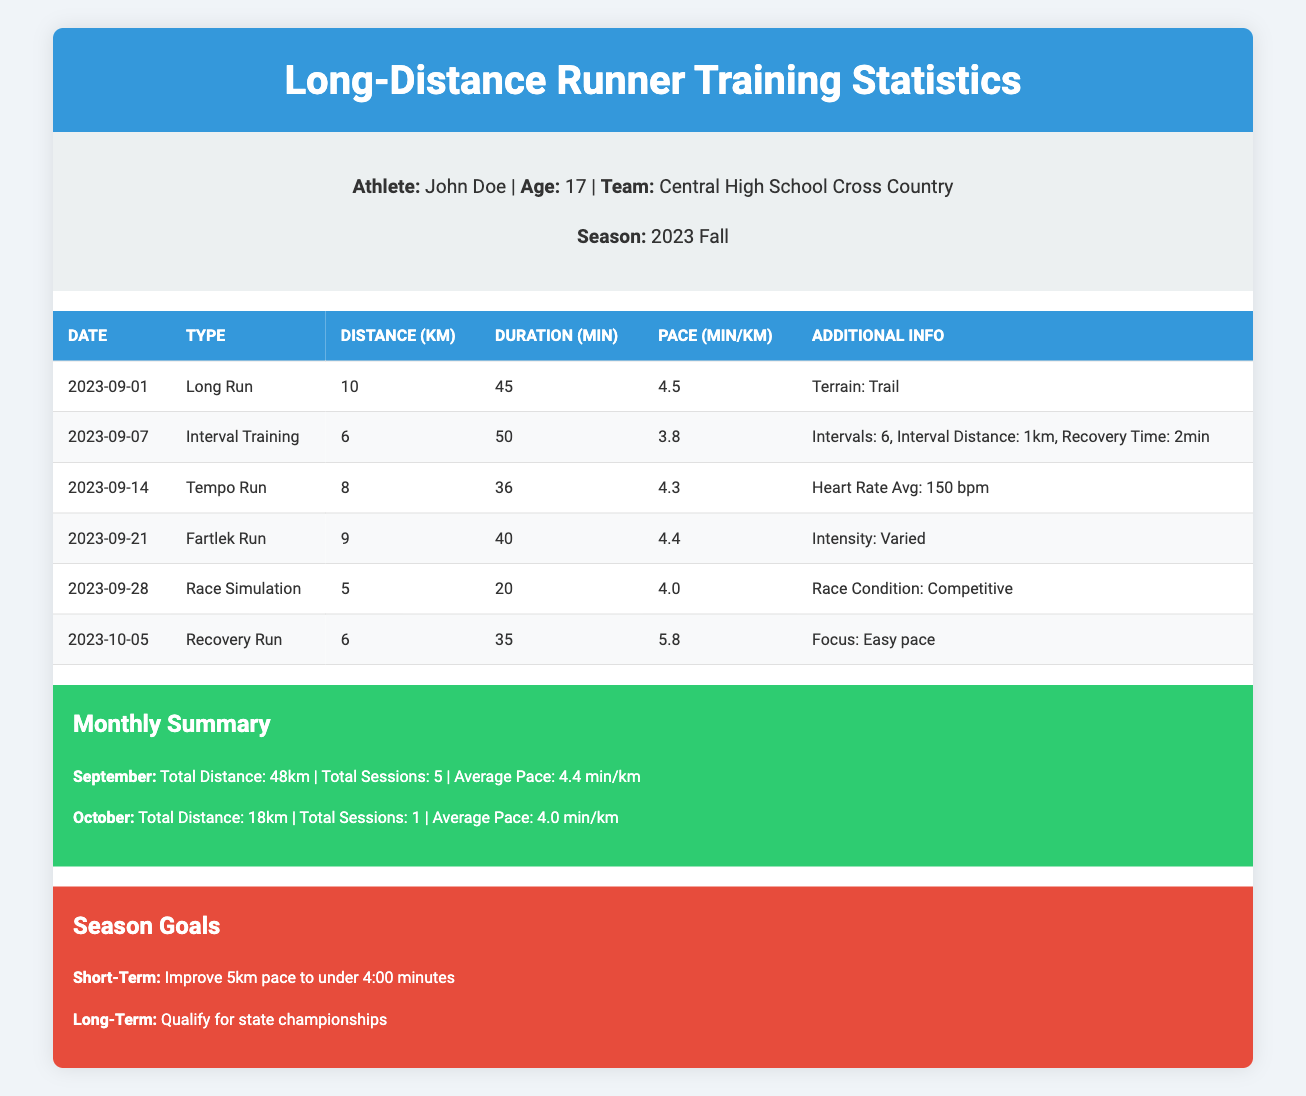What types of training sessions did John Doe complete in September? The table lists different training sessions conducted by John Doe. By reviewing the "Type" column for the dates in September (September 1, 7, 14, 21, 28), the recorded types include "Long Run," "Interval Training," "Tempo Run," "Fartlek Run," and "Race Simulation."
Answer: Long Run, Interval Training, Tempo Run, Fartlek Run, Race Simulation What was the average pace of John Doe's training sessions in September? To find the average pace for September, we should focus on the "Pace (min/km)" column for sessions in September: 4.5, 3.8, 4.3, 4.4, and 4.0. We add these values: 4.5 + 3.8 + 4.3 + 4.4 + 4.0 = 21.0, then divide by the number of sessions (5). The average pace is 21.0/5 = 4.2.
Answer: 4.2 Did John Doe have a recovery run during his training sessions? Based on the table, a recovery run is defined as "Recovery Run," which occurs on October 5. Since recovery runs are generally considered a separate type, we can confirm that he had this session.
Answer: Yes How many kilometers did John Doe run in September? The total distance ran in September is detailed in the "Monthly Summary" section, specifying that he ran a total distance of 48 kilometers.
Answer: 48 km What was the average heart rate during John Doe's tempo run? The table indicates that the average heart rate during the tempo run on September 14 is 150 bpm, which allows us to identify this specific data point directly from the row corresponding to the tempo run training session.
Answer: 150 bpm What is the overall percent decrease in the average pace from September to October? The average pace in September is 4.4 minutes per kilometer (as noted in the Monthly Summary), and for October, it's 4.0 minutes per kilometer. The percent decrease can be calculated by taking the difference (4.4 - 4.0 = 0.4), dividing by the September pace: 0.4/4.4 = 0.0909, and then multiplying by 100 to convert to a percentage, resulting in an overall percent decrease of approximately 9.09%.
Answer: 9.09% Which session had the fastest pace and what was it? By reviewing the "Pace (min/km)" column across all training sessions, the fastest pace is found during the interval training session on September 7, which recorded an average pace of 3.8 minutes per kilometer.
Answer: 3.8 min/km How many total training sessions did John Doe complete in October? The "Monthly Summary" section provides total sessions for October, indicating he completed only 1 training session in that month.
Answer: 1 session 